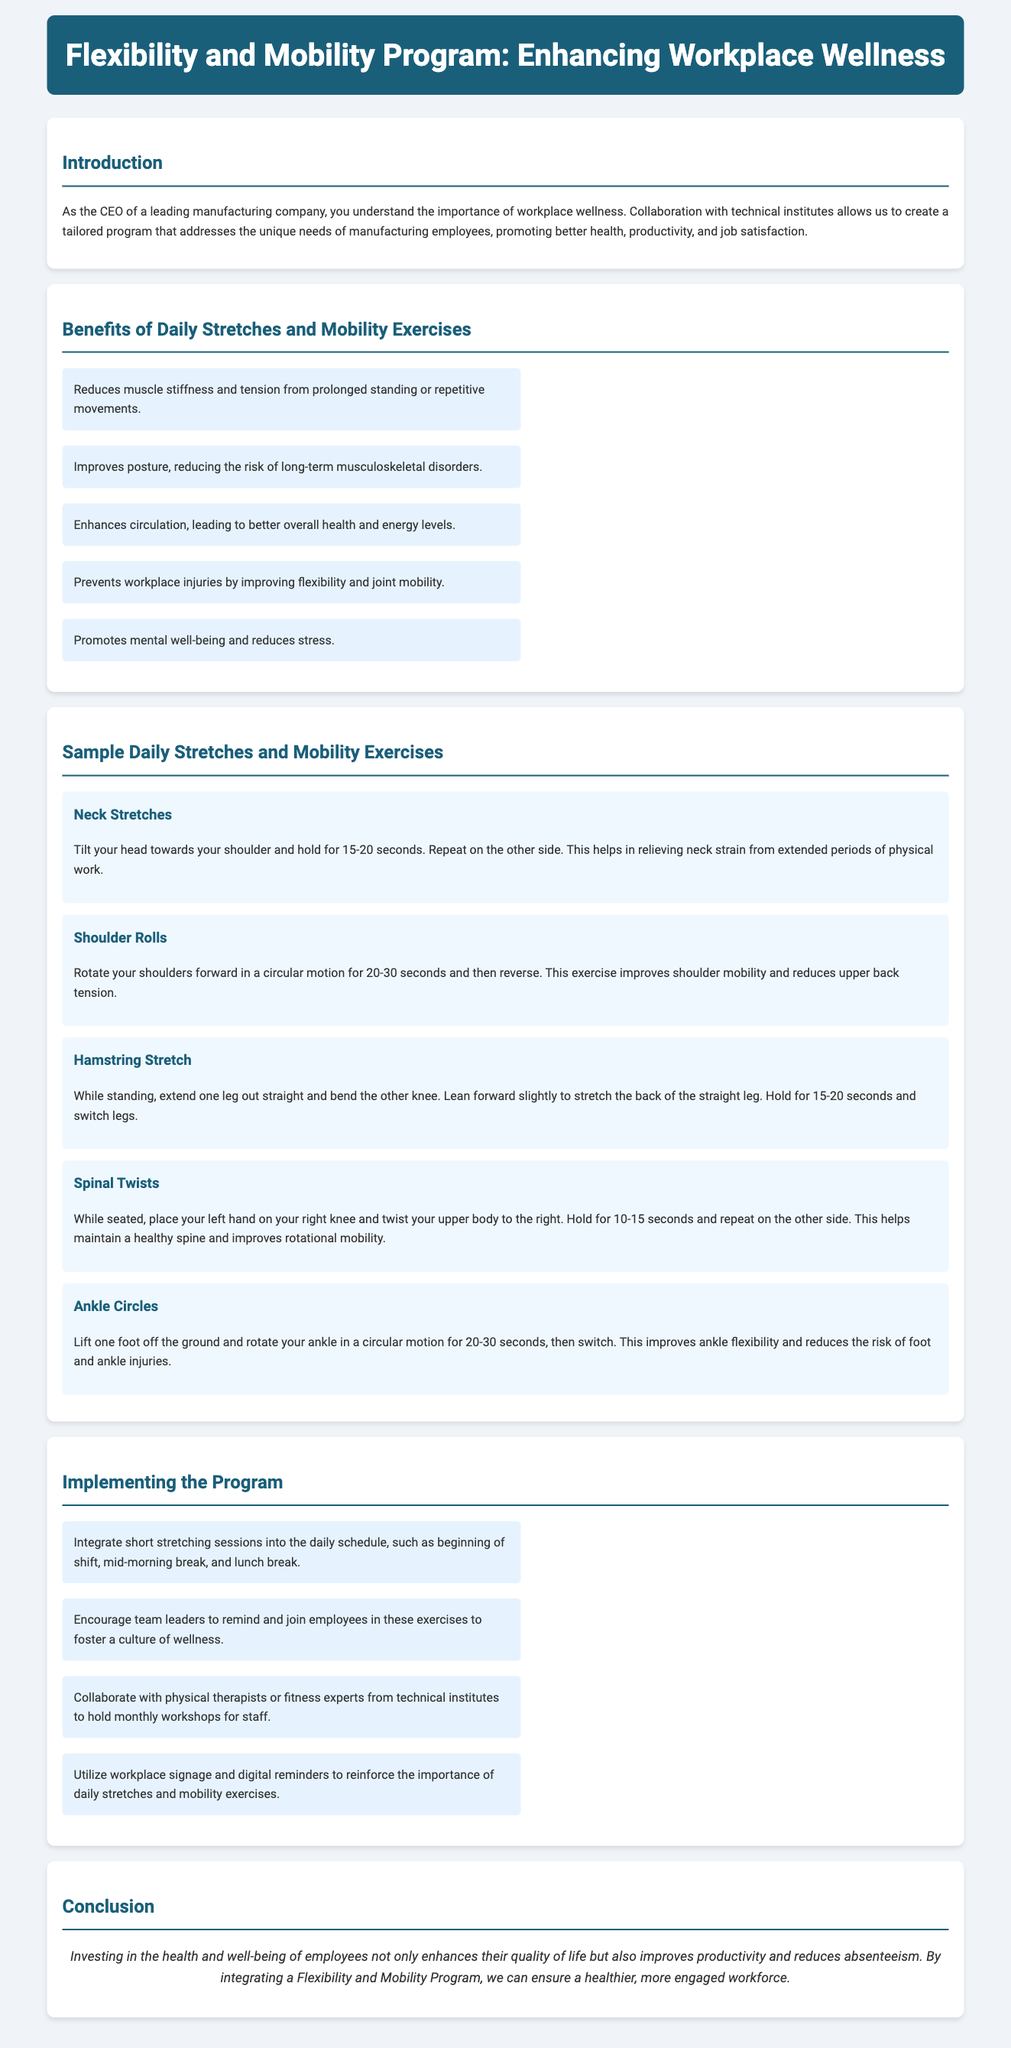what is the title of the program? The title of the program is stated in the header of the document, which is "Flexibility and Mobility Program: Enhancing Workplace Wellness."
Answer: Flexibility and Mobility Program: Enhancing Workplace Wellness how many benefits are listed for daily stretches and mobility exercises? The document lists five benefits in the section titled "Benefits of Daily Stretches and Mobility Exercises."
Answer: 5 what is one of the sample exercises mentioned in the document? The document provides a list of sample exercises, including "Neck Stretches" as the first mentioned exercise.
Answer: Neck Stretches what does the hamstring stretch target? The hamstring stretch aims to relieve stiffness in the back of the straight leg, promoting flexibility.
Answer: Back of the straight leg who should encourage participation in the exercises according to the implementation section? The document states that team leaders should encourage and join employees in the exercises to foster a culture of wellness.
Answer: Team leaders what is the main conclusion drawn from implementing the Flexibility and Mobility Program? The conclusion emphasizes the health benefits for employees, which leads to improved productivity and reduced absenteeism.
Answer: Improved productivity and reduced absenteeism what is one method suggested for integrating the program into the workplace? One suggested method is to integrate short stretching sessions into the daily schedule, such as during lunch breaks.
Answer: Short stretching sessions during lunch breaks how long should you hold the neck stretches? The document specifies that neck stretches should be held for 15-20 seconds.
Answer: 15-20 seconds what color is used for the header background? The header background color is specified in the style and is described as "#1a5f7a."
Answer: #1a5f7a 